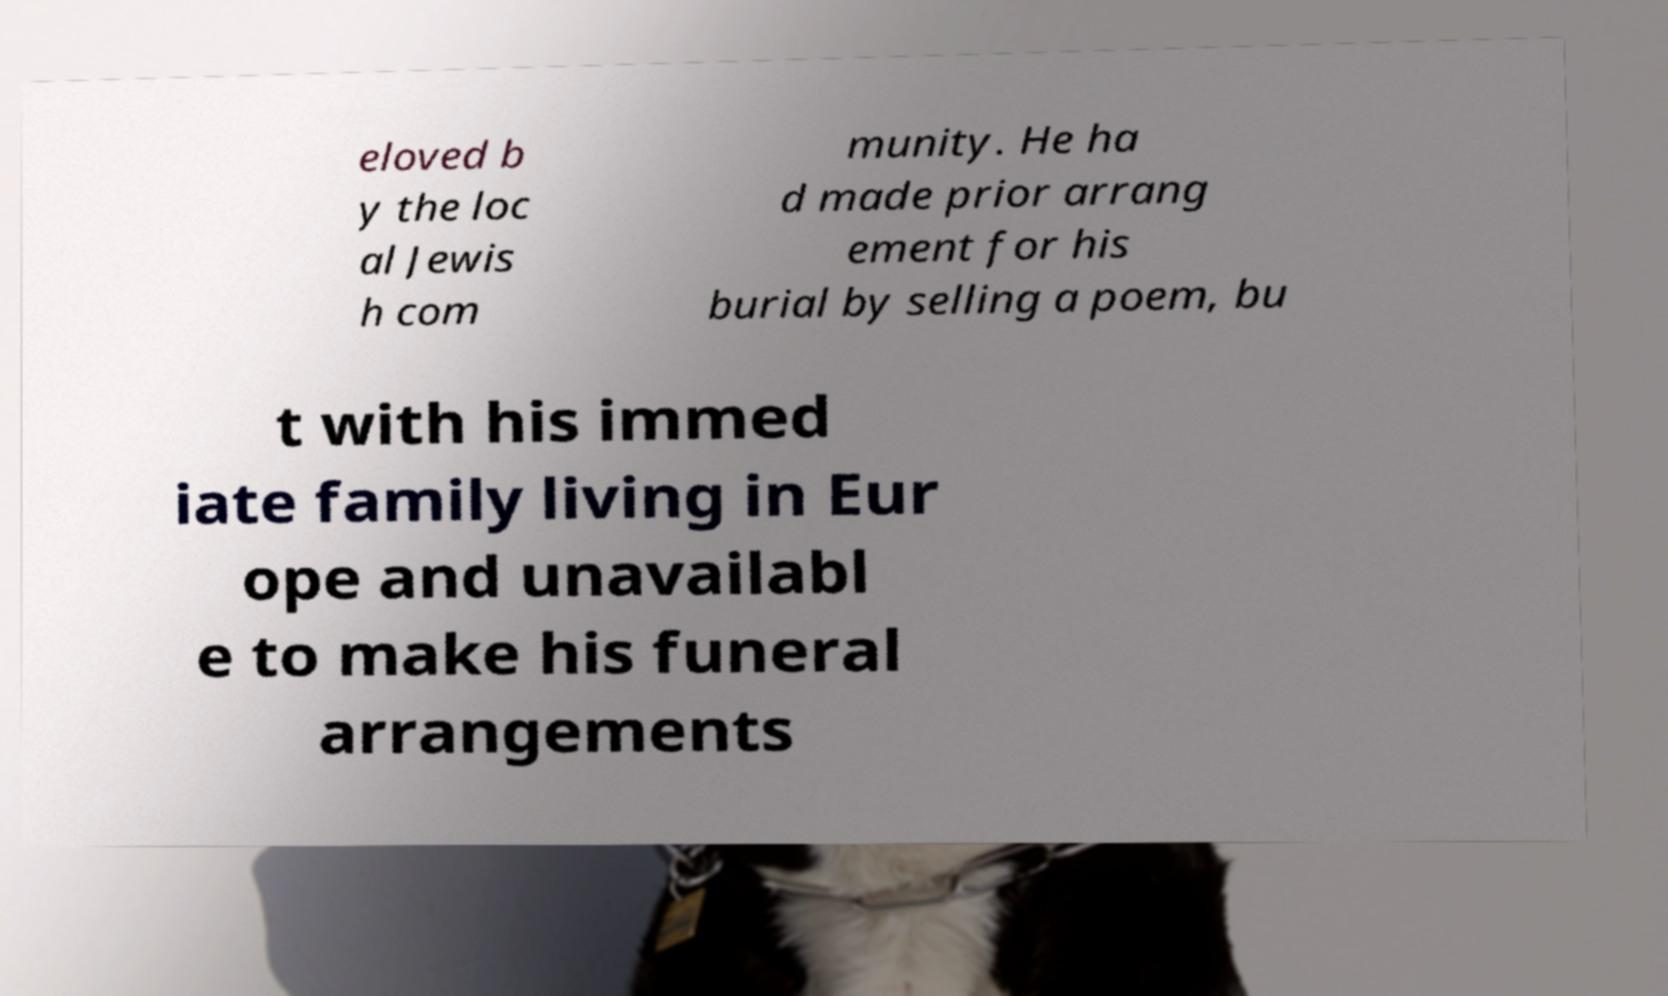For documentation purposes, I need the text within this image transcribed. Could you provide that? eloved b y the loc al Jewis h com munity. He ha d made prior arrang ement for his burial by selling a poem, bu t with his immed iate family living in Eur ope and unavailabl e to make his funeral arrangements 